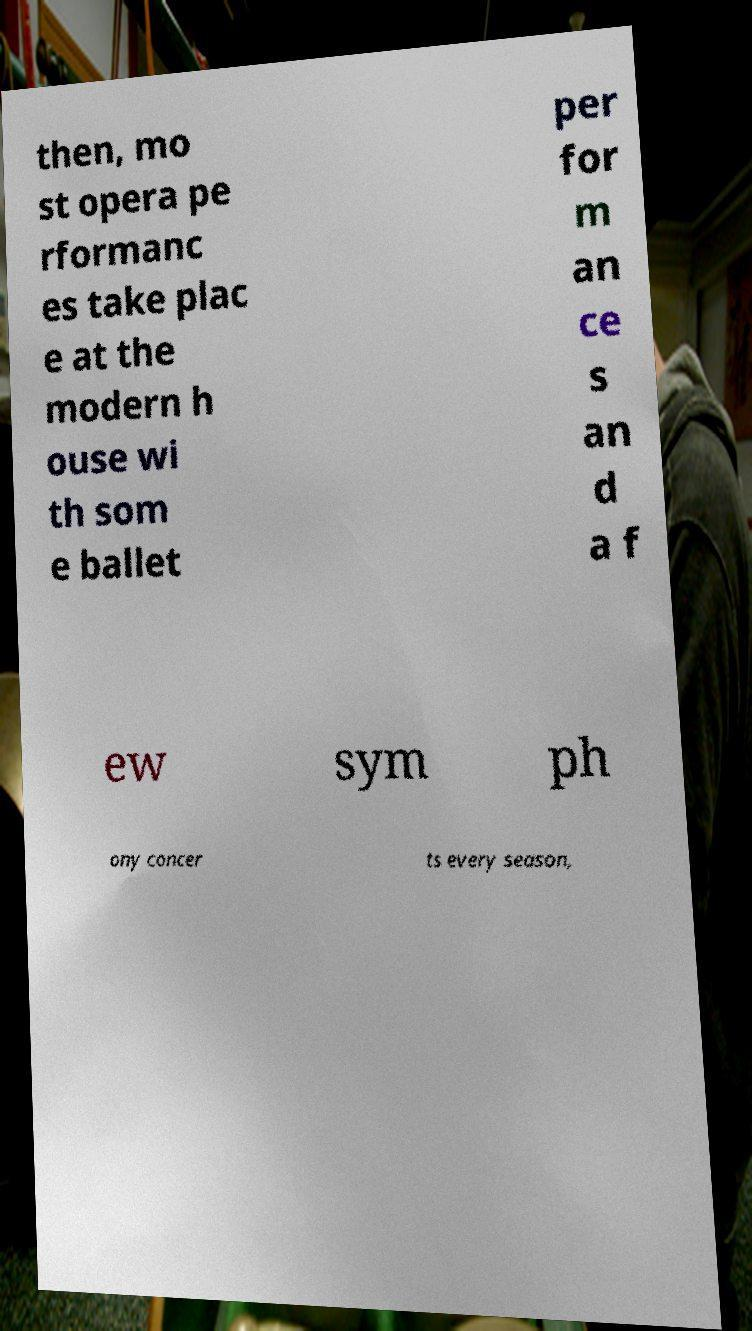Please read and relay the text visible in this image. What does it say? then, mo st opera pe rformanc es take plac e at the modern h ouse wi th som e ballet per for m an ce s an d a f ew sym ph ony concer ts every season, 